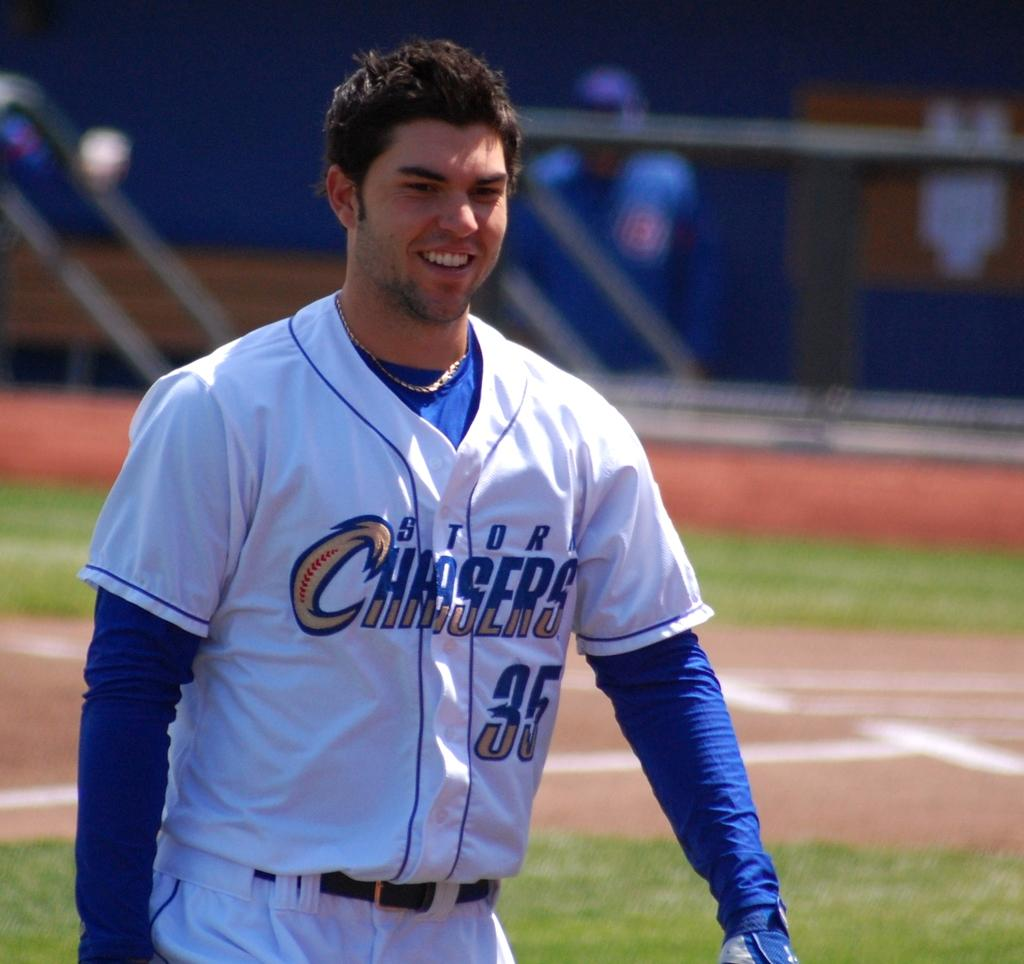Provide a one-sentence caption for the provided image. a happy smiling baseball player guy with STDR Chasers 35 on his uniform. 